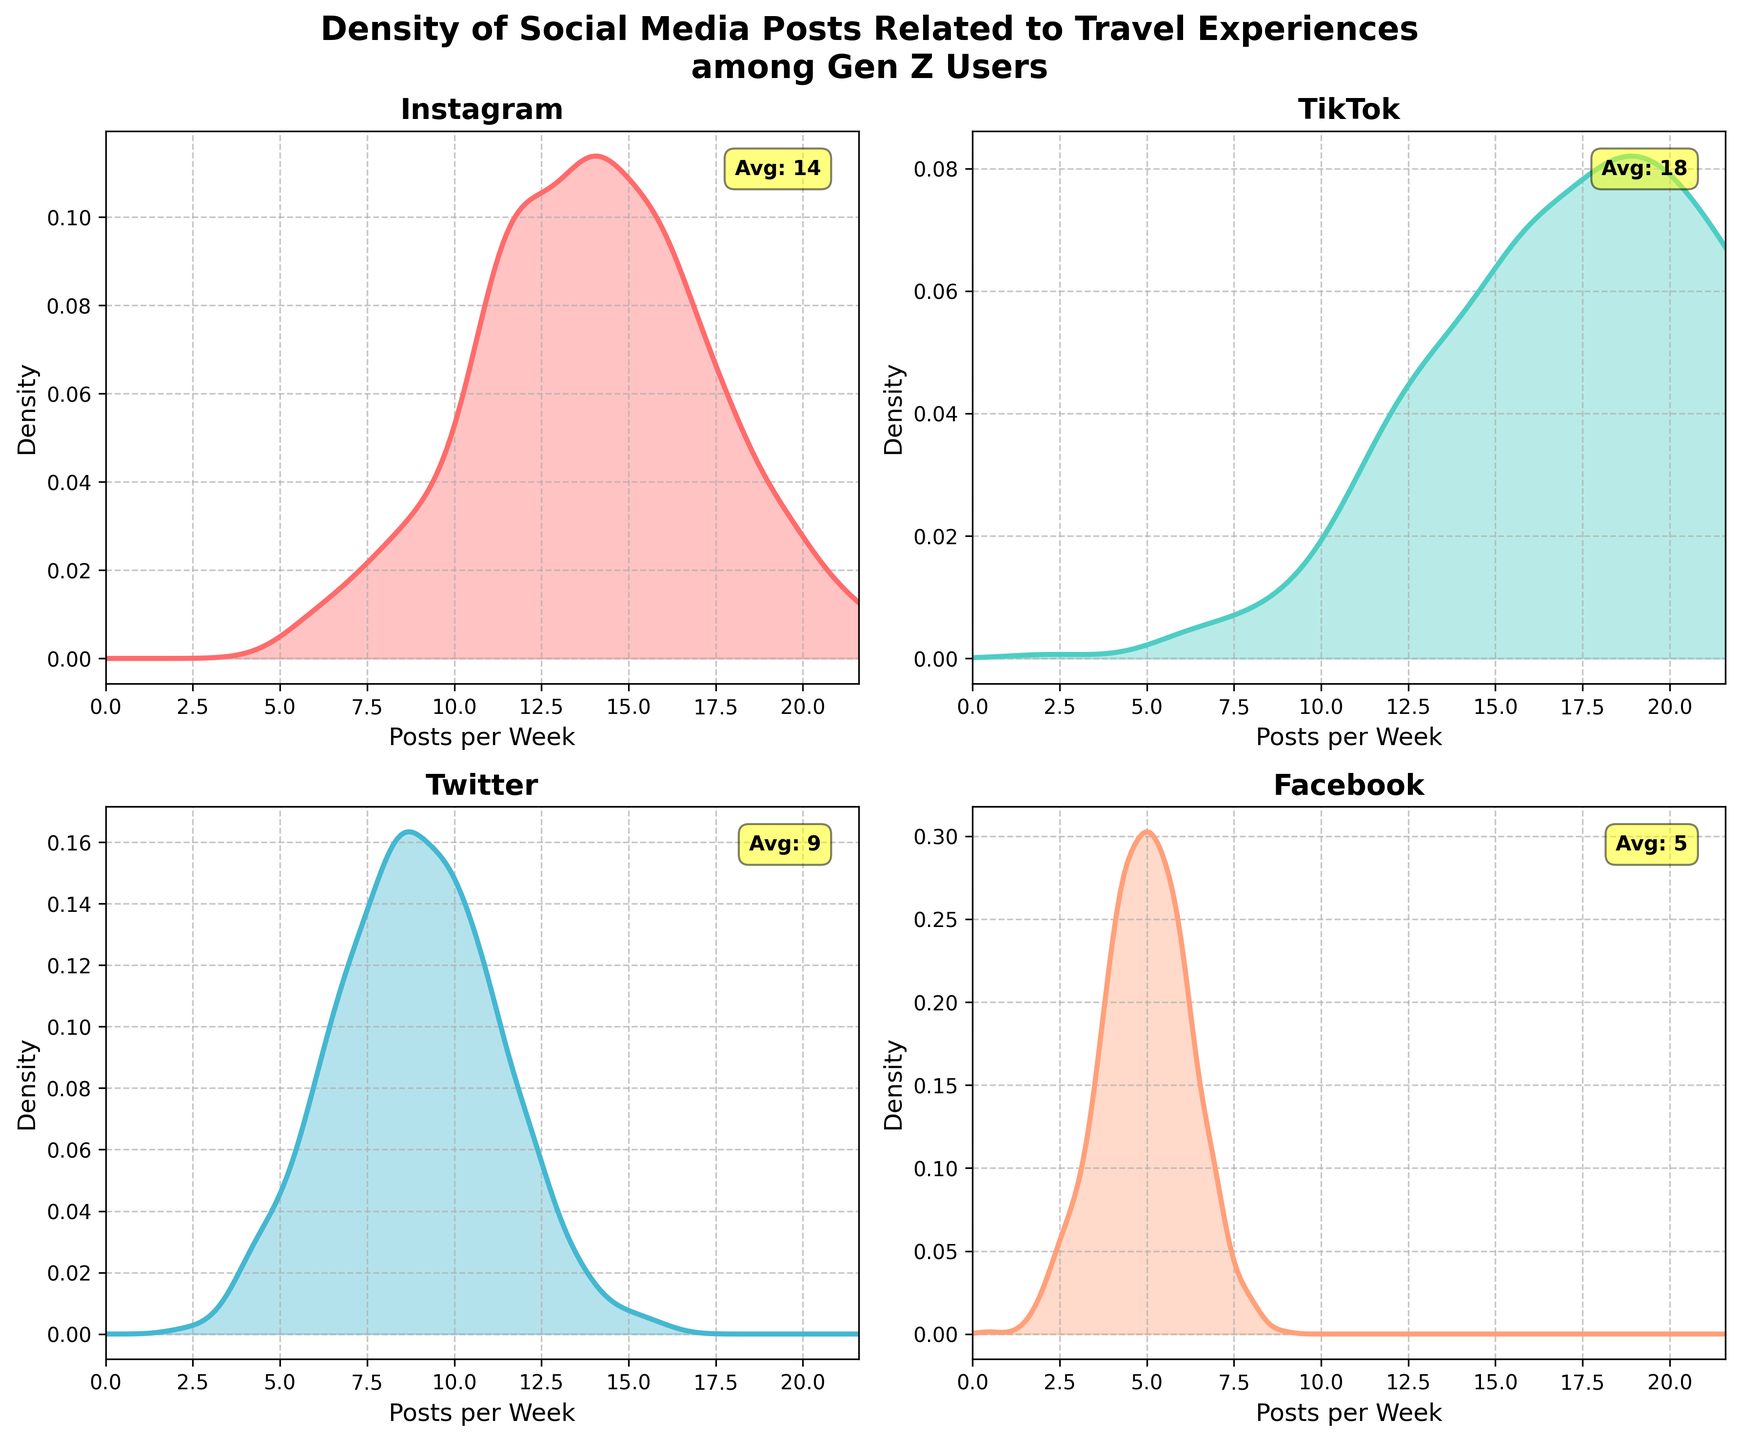What is the title of the figure? The title is displayed at the top of the figure in bold text, summarizing the overall content of the plot.
Answer: Density of Social Media Posts Related to Travel Experiences among Gen Z Users Which platform has the highest average number of posts per week? The average number of posts per week is annotated in yellow box text on each subplot. The platform with the highest value is seen in the annotation text.
Answer: TikTok What color represents the density plot for Instagram? Each subplot has a distinct color for the density plot, and the specific color for each platform is consistent across platforms on the plot.
Answer: Red What is the range of the x-axis for all subplots? The x-axis range is specified by the x-axis limits, which are set from 0 to the maximum value of posts per week plus 20% of that value, as seen in multiple subplots.
Answer: 0 to 21.6 Which platform has the lowest density peak? The height of the density peak is determined by comparing the highest points of each density curve. The platform with the lowest peak value is the answer.
Answer: Facebook Compare the average number of posts between Instagram and Snapchat. The average posts per week for Instagram and Snapchat can be read from the annotations in their respective subplots.
Answer: Instagram has 14 posts per week and Snapchat has 11 How does the density of posts on TikTok compare to Instagram? By comparing the shape and height of the density plots for TikTok and Instagram, we can see that TikTok has a slightly wider spread and a higher density peak than Instagram.
Answer: TikTok has a higher density and wider spread of posts On which platform do we observe the most variability in the number of posts per week? Variability can be inferred from the spread of the density plots. The platform with the widest spread in the density distribution indicates higher variability.
Answer: TikTok What is the average number of posts per week for Facebook compared to Reddit? By comparing the annotated average posts per week in the subplots for Facebook and Reddit, we can determine the specific values.
Answer: Facebook has 5 posts per week and Reddit has 6 Which subplot has the most filled area with color and what could this indicate? The subplot with the most filled area under the density curve, typically indicates a higher frequency or number of posts. This can be observed in the density plot fill color area.
Answer: TikTok's subplot has the most filled area, indicating a higher frequency of posts 